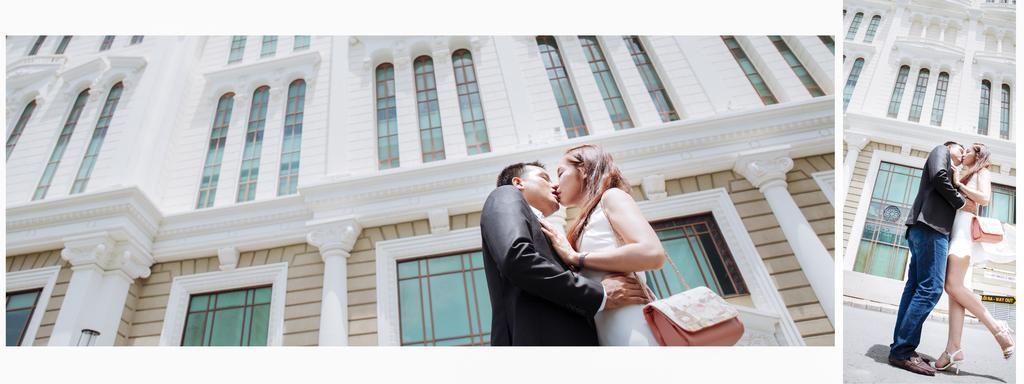What type of pictures are present in the image? There are collage pictures of a man and a woman in the image. Can you describe the background of the image? There is a building in the background of the image. What type of linen is being used to create the collage pictures in the image? There is no mention of linen being used in the image; the collage pictures are made of other materials. 